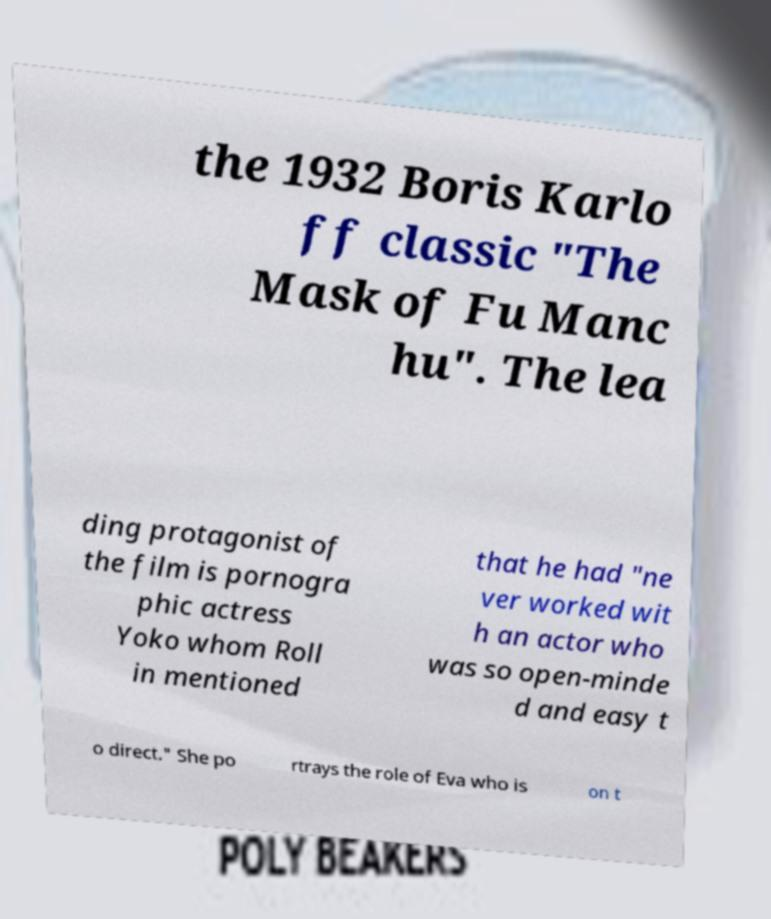For documentation purposes, I need the text within this image transcribed. Could you provide that? the 1932 Boris Karlo ff classic "The Mask of Fu Manc hu". The lea ding protagonist of the film is pornogra phic actress Yoko whom Roll in mentioned that he had "ne ver worked wit h an actor who was so open-minde d and easy t o direct." She po rtrays the role of Eva who is on t 